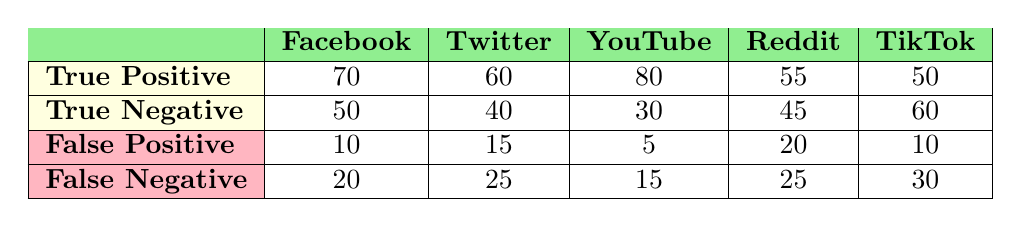What is the true positive rate for YouTube? The true positive rate is calculated using the formula: True Positive Rate = True Positive / (True Positive + False Negative). For YouTube, True Positive is 80 and False Negative is 15. Thus, the true positive rate is 80 / (80 + 15) = 80 / 95 = 0.8421 or 84.21%.
Answer: 84.21% What is the total number of false positives across all platforms? The total number of false positives can be computed by adding the false positives for each platform: (10 + 15 + 5 + 20 + 10) = 70.
Answer: 70 Which platform has the highest true negative? By observing the true negative values: Facebook has 50, Twitter 40, YouTube 30, Reddit 45, and TikTok 60. The highest value is 60 from TikTok.
Answer: TikTok Is the number of false negatives for Reddit greater than that for Twitter? The number of false negatives for Reddit is 25 while for Twitter it is 25. Since the values are equal, the answer is no.
Answer: No What is the average number of true positives among all platforms? To find the average, sum the true positives for each platform: (70 + 60 + 80 + 55 + 50) = 315. There are 5 platforms, so the average is 315 / 5 = 63.
Answer: 63 